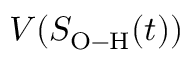Convert formula to latex. <formula><loc_0><loc_0><loc_500><loc_500>V ( S _ { O - H } ( t ) )</formula> 